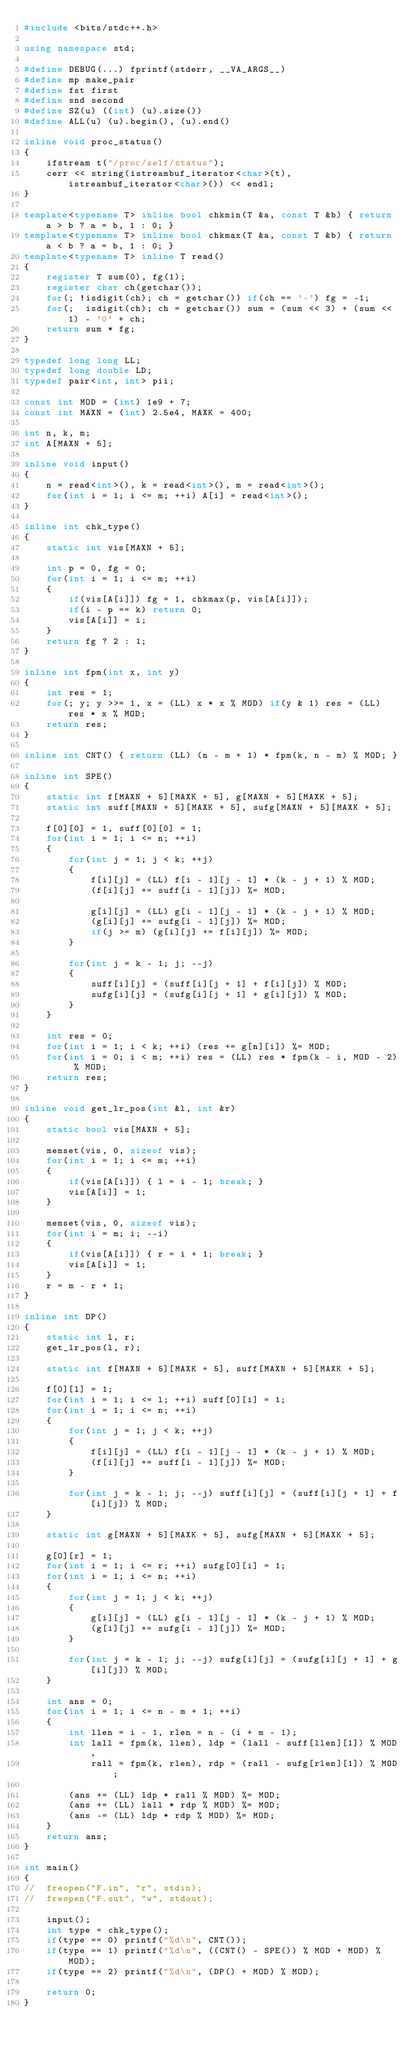Convert code to text. <code><loc_0><loc_0><loc_500><loc_500><_C++_>#include <bits/stdc++.h>

using namespace std;

#define DEBUG(...) fprintf(stderr, __VA_ARGS__)
#define mp make_pair
#define fst first
#define snd second
#define SZ(u) ((int) (u).size())
#define ALL(u) (u).begin(), (u).end()

inline void proc_status()
{
    ifstream t("/proc/self/status");
    cerr << string(istreambuf_iterator<char>(t), istreambuf_iterator<char>()) << endl;
}

template<typename T> inline bool chkmin(T &a, const T &b) { return a > b ? a = b, 1 : 0; }
template<typename T> inline bool chkmax(T &a, const T &b) { return a < b ? a = b, 1 : 0; }
template<typename T> inline T read()
{
	register T sum(0), fg(1);
	register char ch(getchar());
	for(; !isdigit(ch); ch = getchar()) if(ch == '-') fg = -1;
	for(;  isdigit(ch); ch = getchar()) sum = (sum << 3) + (sum << 1) - '0' + ch;
	return sum * fg;
}

typedef long long LL;
typedef long double LD;
typedef pair<int, int> pii;

const int MOD = (int) 1e9 + 7;
const int MAXN = (int) 2.5e4, MAXK = 400;

int n, k, m;
int A[MAXN + 5];

inline void input()
{
	n = read<int>(), k = read<int>(), m = read<int>();
	for(int i = 1; i <= m; ++i) A[i] = read<int>();
}

inline int chk_type()
{
	static int vis[MAXN + 5];

	int p = 0, fg = 0;
	for(int i = 1; i <= m; ++i)
	{
		if(vis[A[i]]) fg = 1, chkmax(p, vis[A[i]]);
		if(i - p == k) return 0;
		vis[A[i]] = i;
	}
	return fg ? 2 : 1;
}

inline int fpm(int x, int y)
{
	int res = 1;
	for(; y; y >>= 1, x = (LL) x * x % MOD) if(y & 1) res = (LL) res * x % MOD;
	return res;
}

inline int CNT() { return (LL) (n - m + 1) * fpm(k, n - m) % MOD; }

inline int SPE()
{
	static int f[MAXN + 5][MAXK + 5], g[MAXN + 5][MAXK + 5];
	static int suff[MAXN + 5][MAXK + 5], sufg[MAXN + 5][MAXK + 5];

	f[0][0] = 1, suff[0][0] = 1;
	for(int i = 1; i <= n; ++i)
	{
		for(int j = 1; j < k; ++j)
		{
			f[i][j] = (LL) f[i - 1][j - 1] * (k - j + 1) % MOD;
			(f[i][j] += suff[i - 1][j]) %= MOD;

			g[i][j] = (LL) g[i - 1][j - 1] * (k - j + 1) % MOD;
			(g[i][j] += sufg[i - 1][j]) %= MOD;
			if(j >= m) (g[i][j] += f[i][j]) %= MOD;
		}

		for(int j = k - 1; j; --j)
		{
			suff[i][j] = (suff[i][j + 1] + f[i][j]) % MOD;
			sufg[i][j] = (sufg[i][j + 1] + g[i][j]) % MOD;
		}
	}

	int res = 0;
	for(int i = 1; i < k; ++i) (res += g[n][i]) %= MOD;
	for(int i = 0; i < m; ++i) res = (LL) res * fpm(k - i, MOD - 2) % MOD;
	return res;
}

inline void get_lr_pos(int &l, int &r)
{
	static bool vis[MAXN + 5];

	memset(vis, 0, sizeof vis);
	for(int i = 1; i <= m; ++i)
	{
		if(vis[A[i]]) { l = i - 1; break; }
		vis[A[i]] = 1;
	}

	memset(vis, 0, sizeof vis);
	for(int i = m; i; --i)
	{
		if(vis[A[i]]) { r = i + 1; break; }
		vis[A[i]] = 1;
	}
	r = m - r + 1;
}

inline int DP()
{
	static int l, r;
	get_lr_pos(l, r);

	static int f[MAXN + 5][MAXK + 5], suff[MAXN + 5][MAXK + 5];

	f[0][l] = 1;
	for(int i = 1; i <= l; ++i) suff[0][i] = 1;
	for(int i = 1; i <= n; ++i)
	{
		for(int j = 1; j < k; ++j)
		{
			f[i][j] = (LL) f[i - 1][j - 1] * (k - j + 1) % MOD;
			(f[i][j] += suff[i - 1][j]) %= MOD;
		}

		for(int j = k - 1; j; --j) suff[i][j] = (suff[i][j + 1] + f[i][j]) % MOD;
	}

	static int g[MAXN + 5][MAXK + 5], sufg[MAXN + 5][MAXK + 5];

	g[0][r] = 1;
	for(int i = 1; i <= r; ++i) sufg[0][i] = 1;
	for(int i = 1; i <= n; ++i)
	{
		for(int j = 1; j < k; ++j)
		{
			g[i][j] = (LL) g[i - 1][j - 1] * (k - j + 1) % MOD;
			(g[i][j] += sufg[i - 1][j]) %= MOD;
		}

		for(int j = k - 1; j; --j) sufg[i][j] = (sufg[i][j + 1] + g[i][j]) % MOD;
	}

	int ans = 0;
	for(int i = 1; i <= n - m + 1; ++i)
	{
		int llen = i - 1, rlen = n - (i + m - 1);
		int lall = fpm(k, llen), ldp = (lall - suff[llen][1]) % MOD,
			rall = fpm(k, rlen), rdp = (rall - sufg[rlen][1]) % MOD;

		(ans += (LL) ldp * rall % MOD) %= MOD;
		(ans += (LL) lall * rdp % MOD) %= MOD;
		(ans -= (LL) ldp * rdp % MOD) %= MOD;
	}
	return ans;
}

int main()
{
//	freopen("F.in", "r", stdin);
//	freopen("F.out", "w", stdout);

	input();
	int type = chk_type();
	if(type == 0) printf("%d\n", CNT());
	if(type == 1) printf("%d\n", ((CNT() - SPE()) % MOD + MOD) % MOD);
	if(type == 2) printf("%d\n", (DP() + MOD) % MOD);

	return 0;
}

</code> 